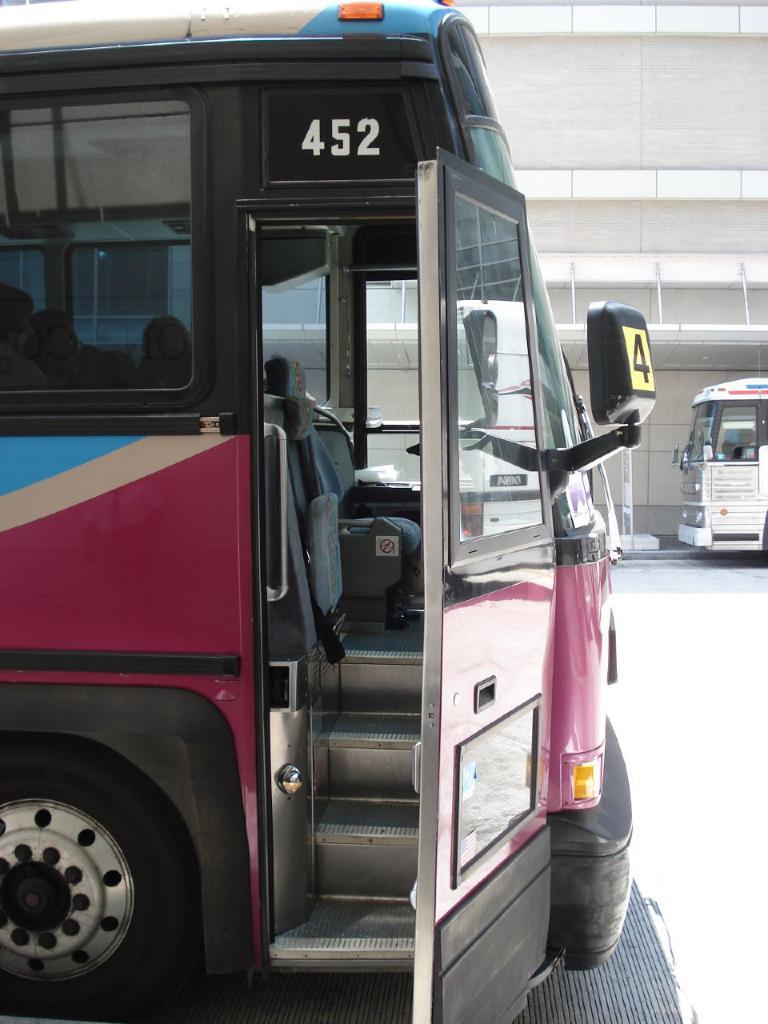What is the number of the bus?
Your answer should be compact. 452. What single digit number is on the buses mirror?
Your answer should be very brief. 4. 